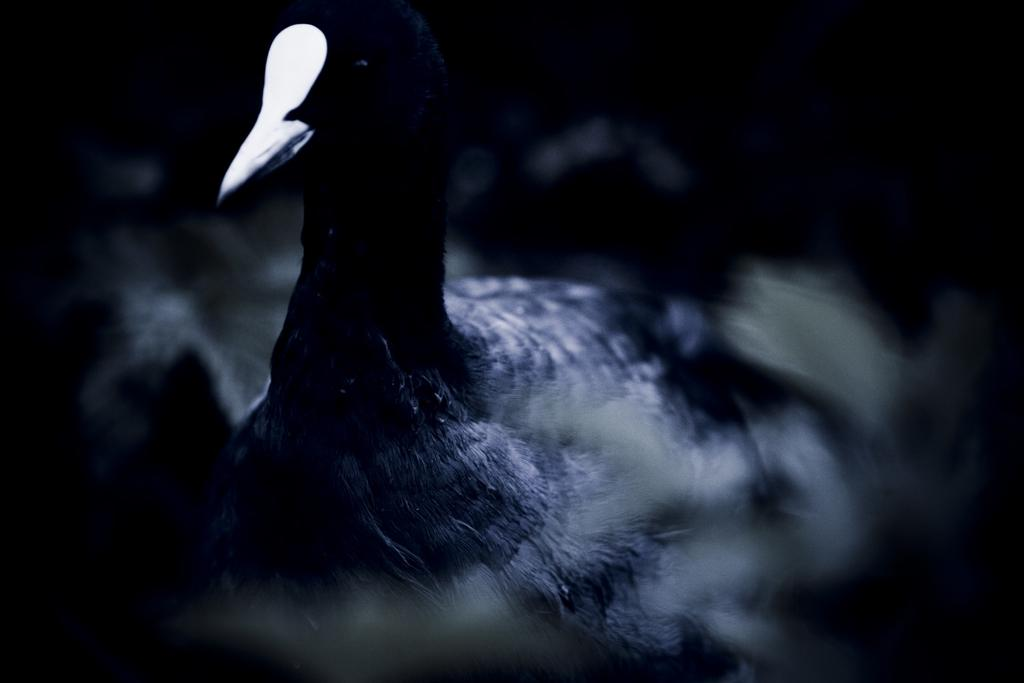What type of animal is in the image? There is a bird in the image. What color is the bird? The bird is black in color. What is the brother of the bird doing in the image? There is no brother of the bird present in the image. What type of beam is holding up the bird in the image? There is no beam present in the image, and the bird is not being held up by any structure. 